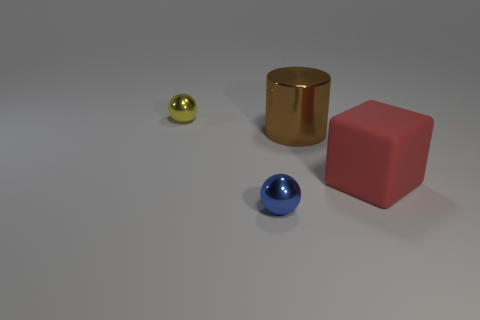How many cubes are either blue matte things or blue metallic objects? 0 